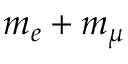Convert formula to latex. <formula><loc_0><loc_0><loc_500><loc_500>m _ { e } + m _ { \mu }</formula> 